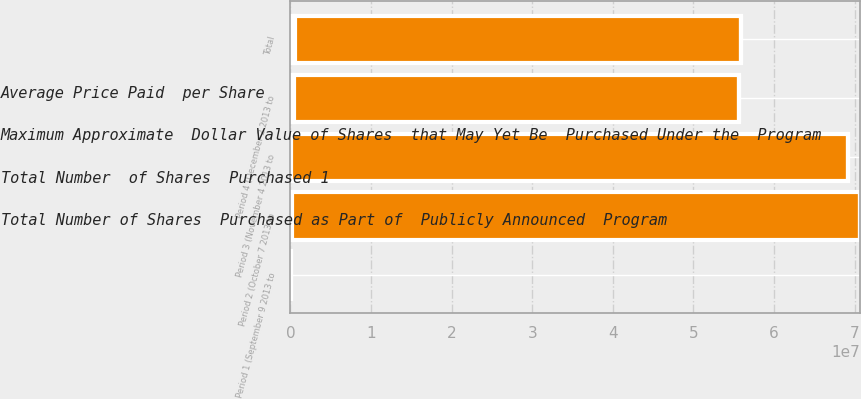<chart> <loc_0><loc_0><loc_500><loc_500><stacked_bar_chart><ecel><fcel>Period 1 (September 9 2013 to<fcel>Period 2 (October 7 2013 to<fcel>Period 3 (November 4 2013 to<fcel>Period 4 (December 2 2013 to<fcel>Total<nl><fcel>Average Price Paid  per Share<fcel>3100<fcel>72170<fcel>23113<fcel>202695<fcel>301078<nl><fcel>Total Number of Shares  Purchased as Part of  Publicly Announced  Program<fcel>61.48<fcel>66.72<fcel>66.87<fcel>68.84<fcel>68.11<nl><fcel>Maximum Approximate  Dollar Value of Shares  that May Yet Be  Purchased Under the  Program<fcel>3100<fcel>71000<fcel>21998<fcel>201105<fcel>297203<nl><fcel>Total Number  of Shares  Purchased 1<fcel>71000<fcel>7.05624e+07<fcel>6.90913e+07<fcel>5.52469e+07<fcel>5.52469e+07<nl></chart> 